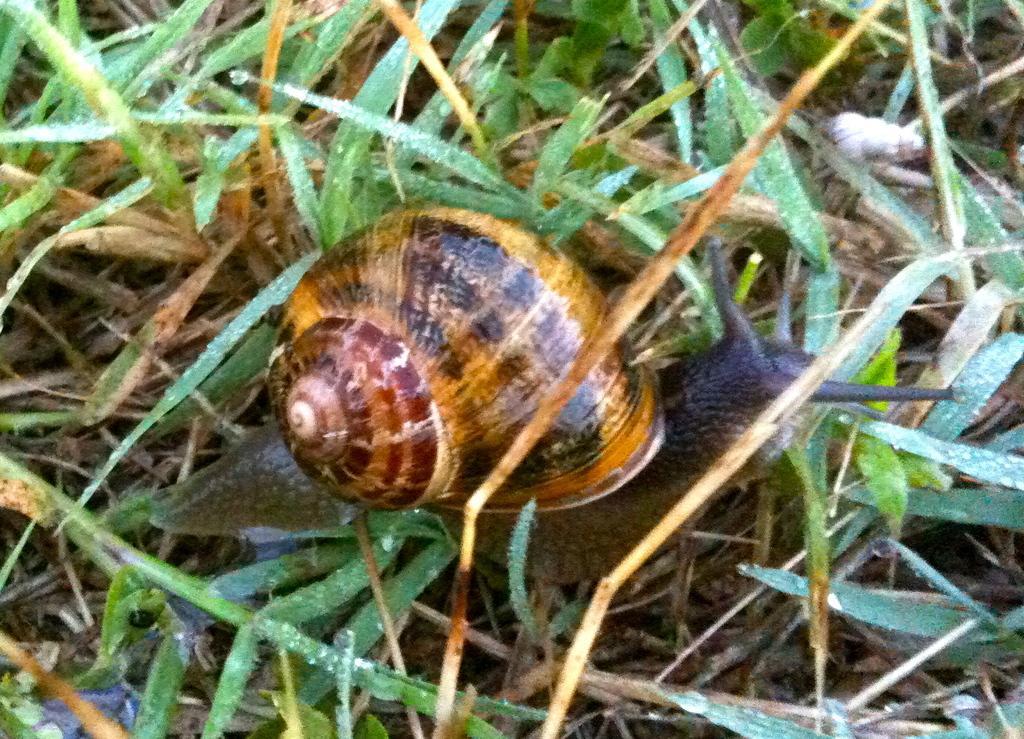Please provide a concise description of this image. In this picture there is a snail on the ground. At the top I can see the green grass. In the top left I can see the water drops on the leaves. 